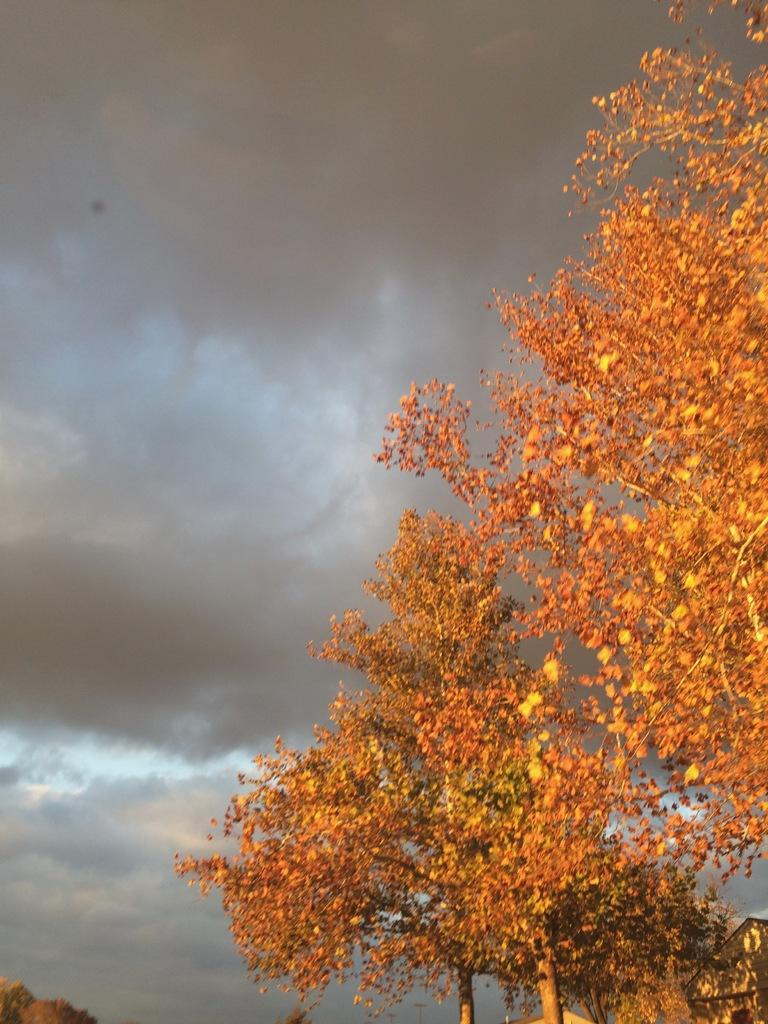What type of vegetation can be seen in the image? There are trees in the image. What color are the leaves on the trees? The leaves on the trees are orange in color. What is the condition of the sky in the image? The sky is cloudy in the image. Can you see any rules being enforced in the image? There are no rules or rule enforcement visible in the image. Is there a tiger present in the image? There is no tiger present in the image. 